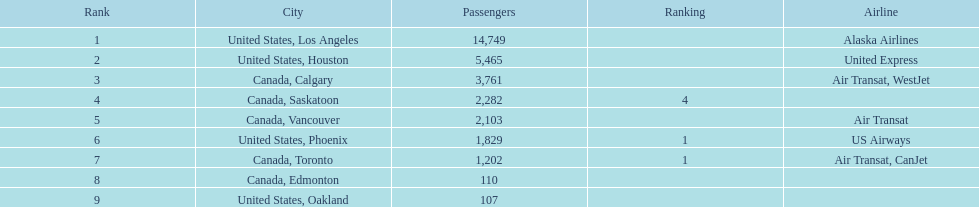What was the total of passengers in phoenix, arizona? 1,829. Parse the table in full. {'header': ['Rank', 'City', 'Passengers', 'Ranking', 'Airline'], 'rows': [['1', 'United States, Los Angeles', '14,749', '', 'Alaska Airlines'], ['2', 'United States, Houston', '5,465', '', 'United Express'], ['3', 'Canada, Calgary', '3,761', '', 'Air Transat, WestJet'], ['4', 'Canada, Saskatoon', '2,282', '4', ''], ['5', 'Canada, Vancouver', '2,103', '', 'Air Transat'], ['6', 'United States, Phoenix', '1,829', '1', 'US Airways'], ['7', 'Canada, Toronto', '1,202', '1', 'Air Transat, CanJet'], ['8', 'Canada, Edmonton', '110', '', ''], ['9', 'United States, Oakland', '107', '', '']]} 